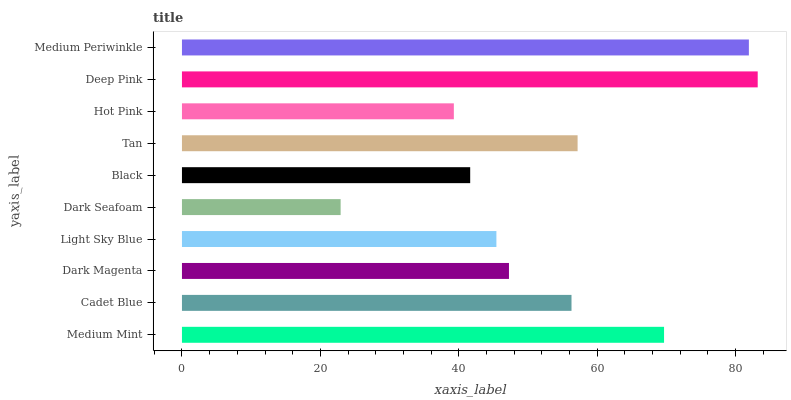Is Dark Seafoam the minimum?
Answer yes or no. Yes. Is Deep Pink the maximum?
Answer yes or no. Yes. Is Cadet Blue the minimum?
Answer yes or no. No. Is Cadet Blue the maximum?
Answer yes or no. No. Is Medium Mint greater than Cadet Blue?
Answer yes or no. Yes. Is Cadet Blue less than Medium Mint?
Answer yes or no. Yes. Is Cadet Blue greater than Medium Mint?
Answer yes or no. No. Is Medium Mint less than Cadet Blue?
Answer yes or no. No. Is Cadet Blue the high median?
Answer yes or no. Yes. Is Dark Magenta the low median?
Answer yes or no. Yes. Is Medium Periwinkle the high median?
Answer yes or no. No. Is Black the low median?
Answer yes or no. No. 